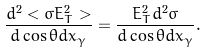<formula> <loc_0><loc_0><loc_500><loc_500>\frac { d ^ { 2 } < \sigma E _ { T } ^ { 2 } > } { d \cos \theta d x _ { \gamma } } = \frac { E _ { T } ^ { 2 } d ^ { 2 } \sigma } { d \cos \theta d x _ { \gamma } } .</formula> 